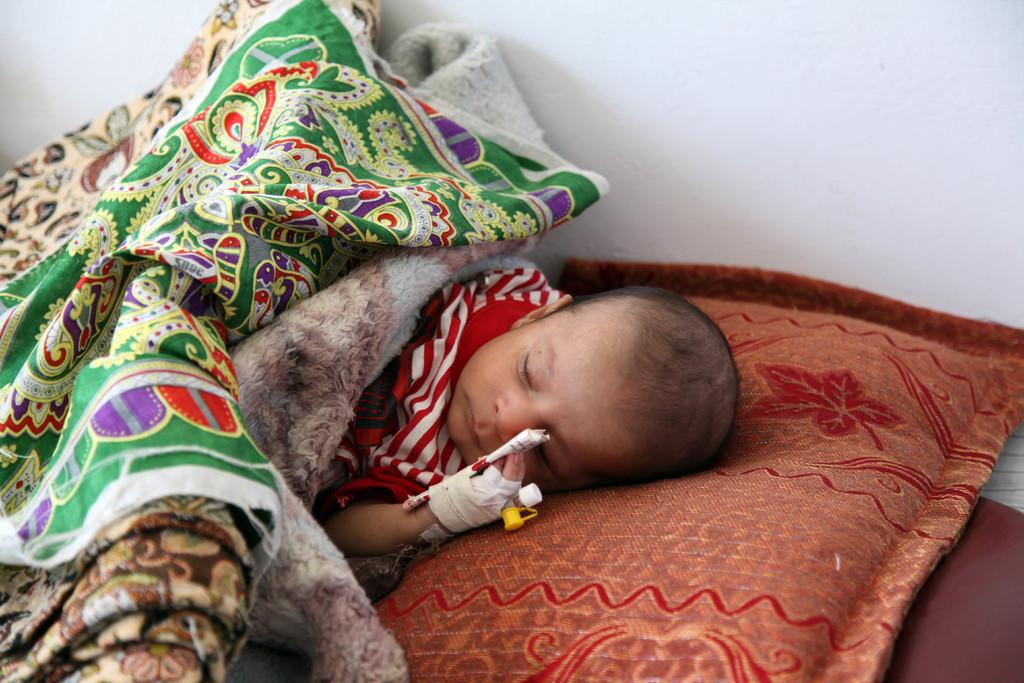What is the main subject of the image? There is a child in the image. What is the child doing in the image? The child is sleeping. What items are present in the image that might be related to sleeping? There is a blanket and a pillow in the image. What can be seen in the background of the image? There is a wall in the image. What type of tax is being discussed in the image? There is no discussion of tax in the image; it features a sleeping child with a blanket and pillow. Can you tell me how many firemen are present in the image? There are no firemen present in the image. 